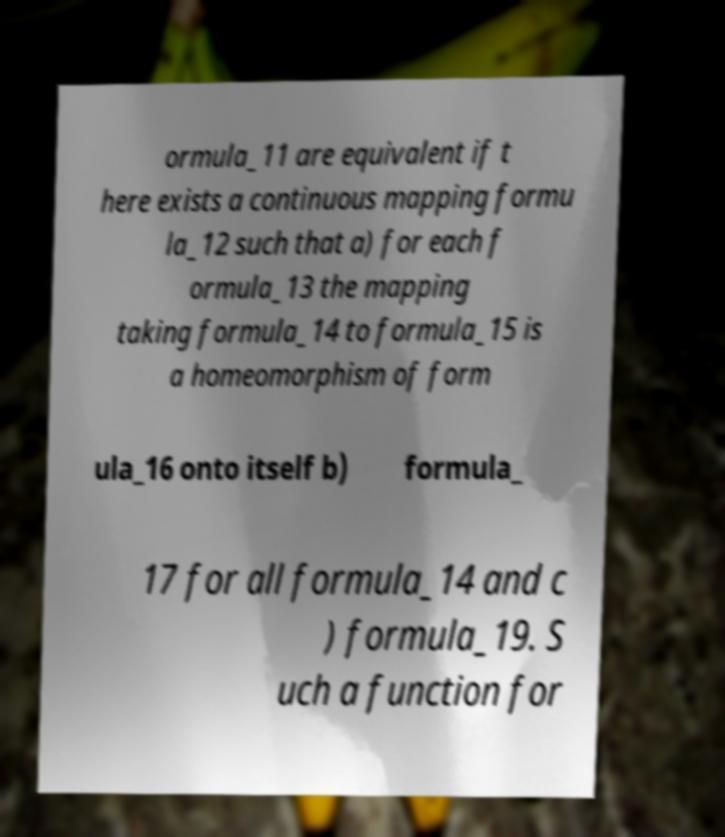Could you assist in decoding the text presented in this image and type it out clearly? ormula_11 are equivalent if t here exists a continuous mapping formu la_12 such that a) for each f ormula_13 the mapping taking formula_14 to formula_15 is a homeomorphism of form ula_16 onto itself b) formula_ 17 for all formula_14 and c ) formula_19. S uch a function for 